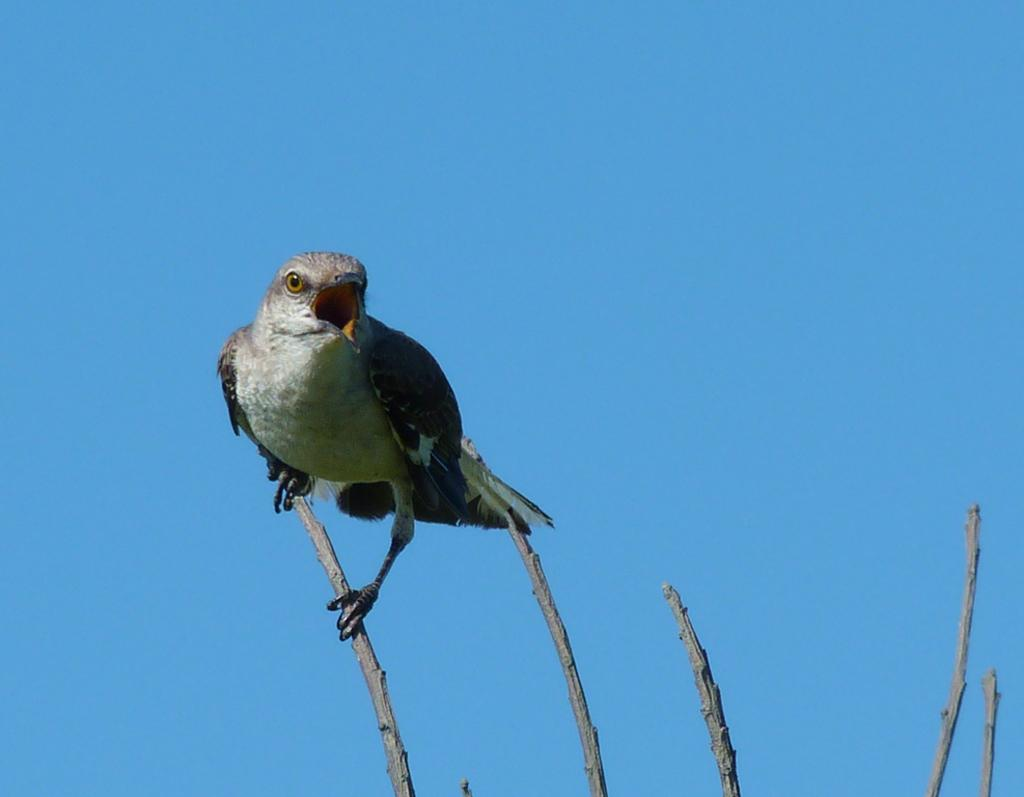What type of animal is in the image? There is a bird in the image. Where is the bird located? The bird is on a branch. What color is the background of the image? The background of the image is blue. How many cattle are visible in the image? There are no cattle present in the image. What type of book is the bird holding in the image? There is no book present in the image, as it features a bird on a branch with a blue background. 